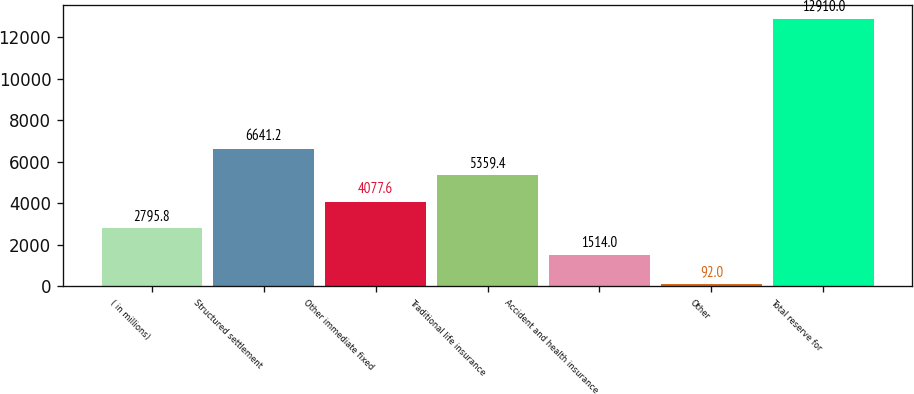<chart> <loc_0><loc_0><loc_500><loc_500><bar_chart><fcel>( in millions)<fcel>Structured settlement<fcel>Other immediate fixed<fcel>Traditional life insurance<fcel>Accident and health insurance<fcel>Other<fcel>Total reserve for<nl><fcel>2795.8<fcel>6641.2<fcel>4077.6<fcel>5359.4<fcel>1514<fcel>92<fcel>12910<nl></chart> 